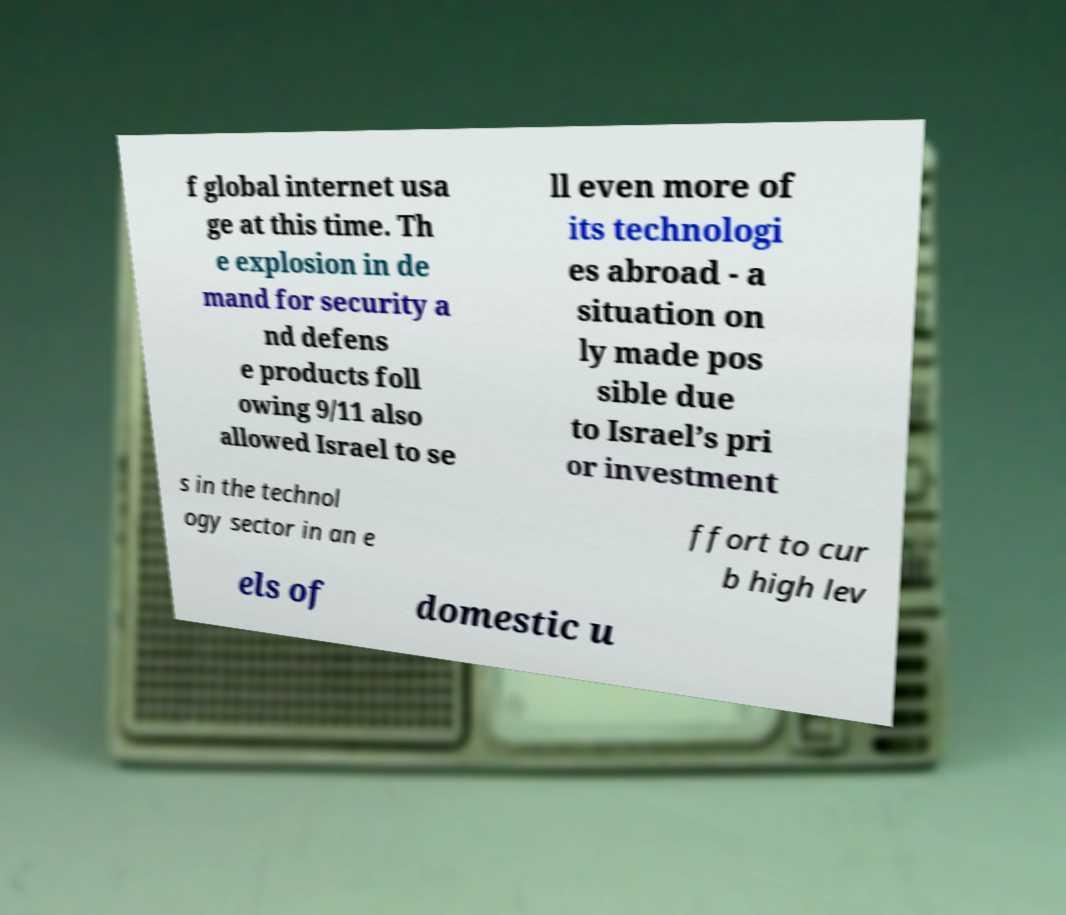There's text embedded in this image that I need extracted. Can you transcribe it verbatim? f global internet usa ge at this time. Th e explosion in de mand for security a nd defens e products foll owing 9/11 also allowed Israel to se ll even more of its technologi es abroad - a situation on ly made pos sible due to Israel’s pri or investment s in the technol ogy sector in an e ffort to cur b high lev els of domestic u 